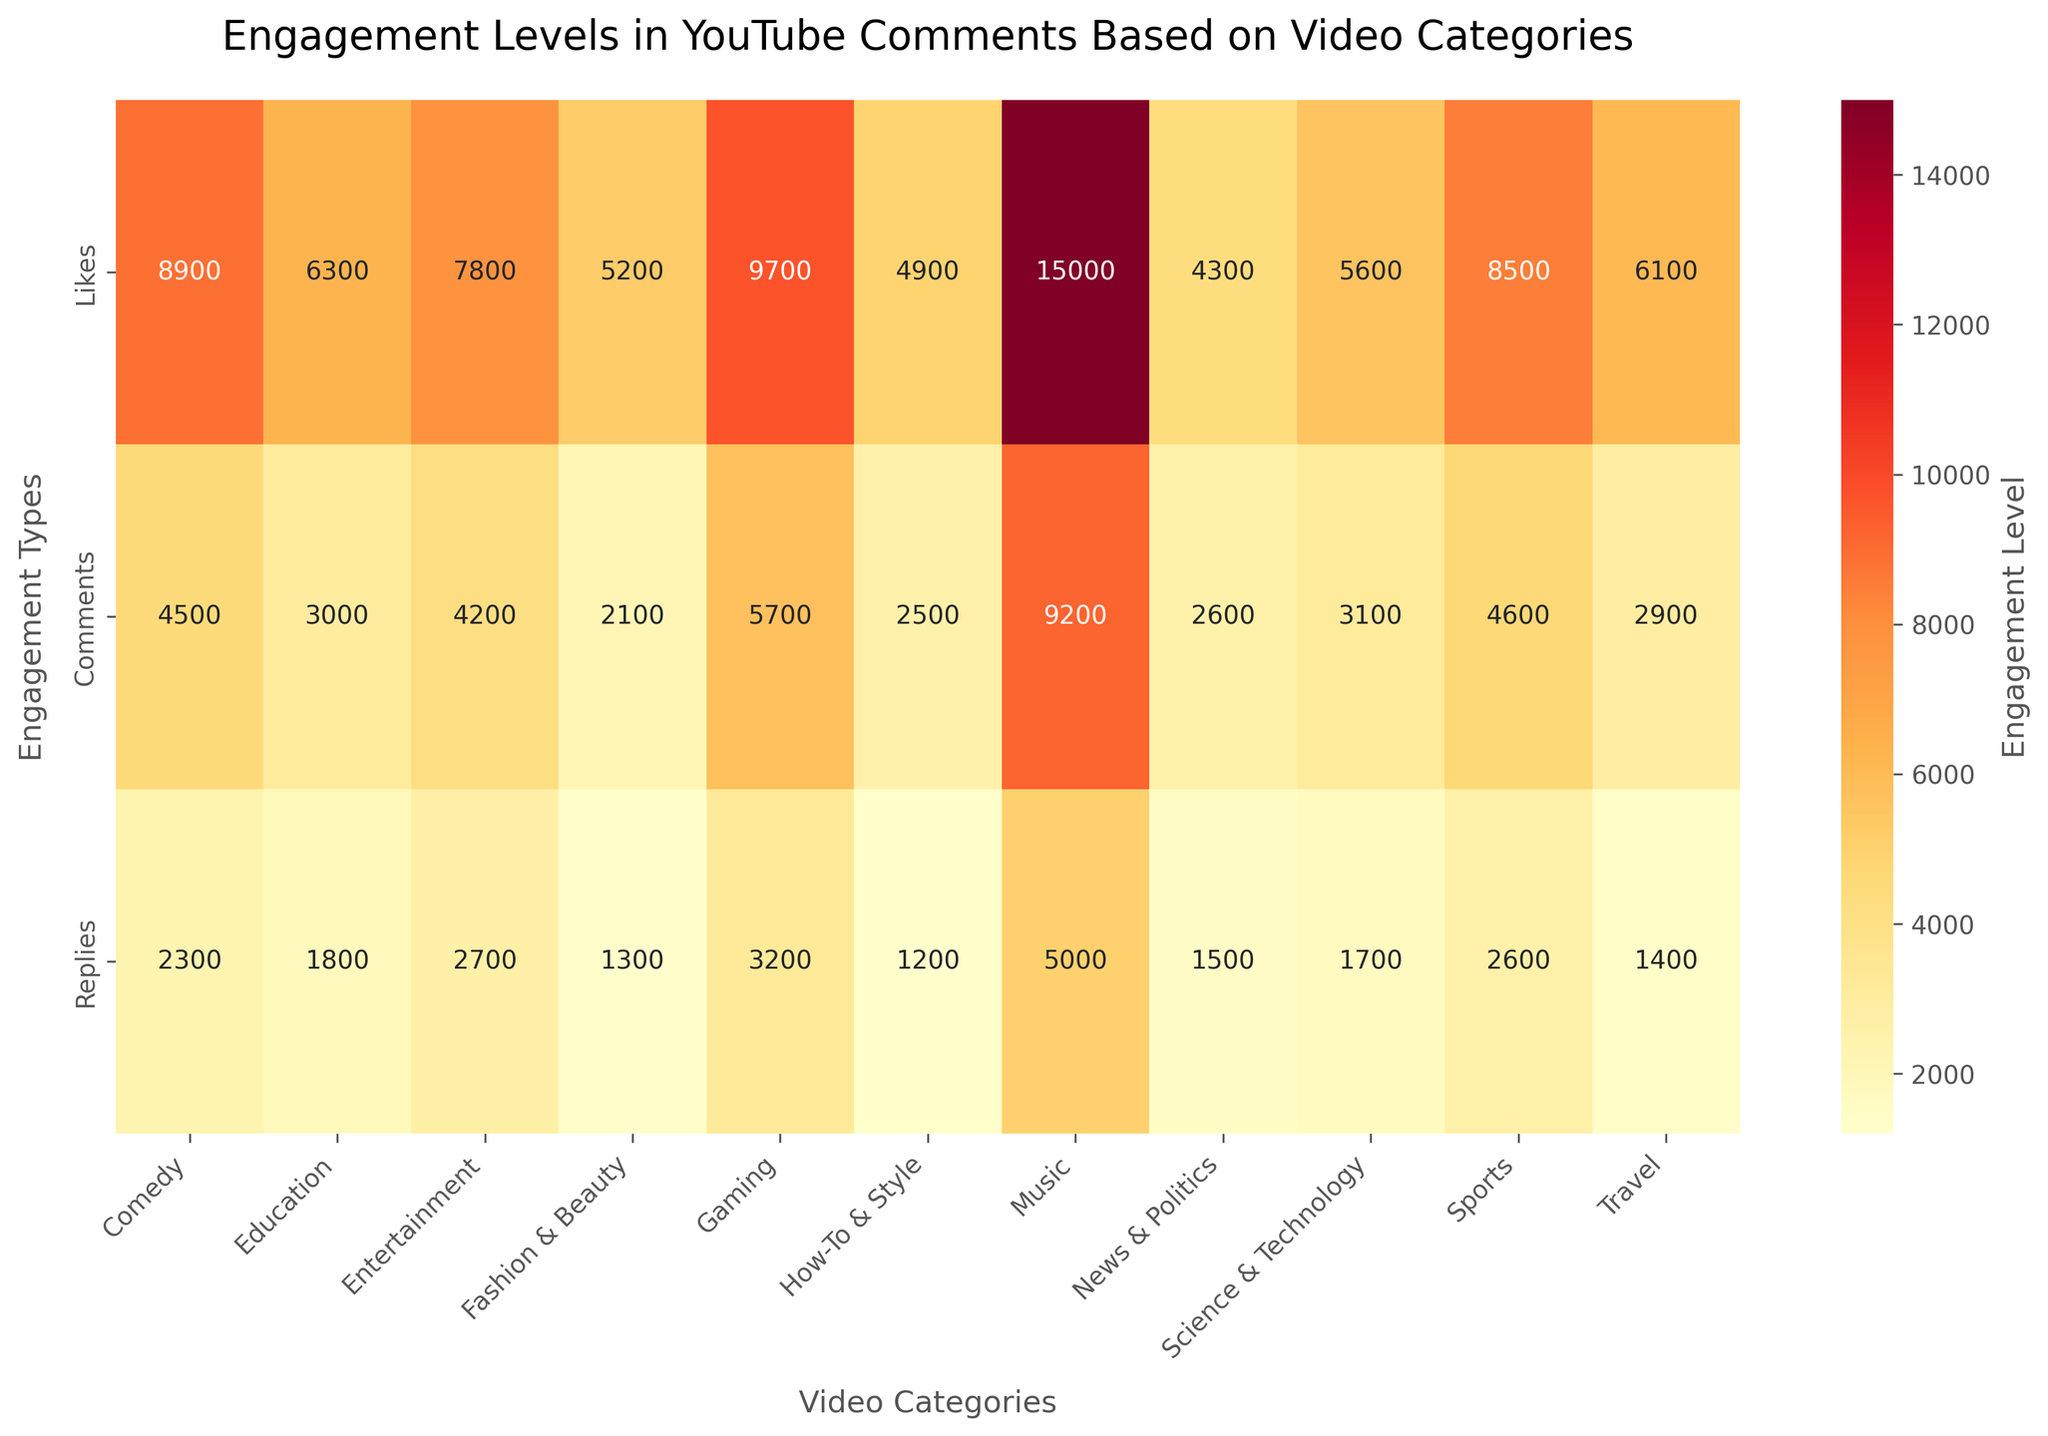What's the total number of likes for the categories with the highest and lowest engagement scores? Locate the categories with the highest and lowest 'Likes' values in the heatmap, which are 'Music' (15000) and 'How-To & Style' (4900) respectively. Sum these values: 15000 + 4900 = 19900.
Answer: 19900 What is the average number of comments across all categories? Sum the 'Comments' values across all categories and divide by the number of categories. (4500 + 3000 + 4200 + 2100 + 5700 + 2500 + 9200 + 2600 + 3100 + 4600 + 2900) / 11 = 4463.64
Answer: 4463.64 Which video category has the highest number of replies? Identify the number linked to 'Replies' and find the highest value, which is 'Music' with 5000.
Answer: Music How does the number of dislikes compare to the number of likes for the 'Gaming' category? Note that the heatmap only depicts likes, comments, and replies, but there is no mention of dislikes. This information cannot be extracted from the figure.
Answer: Not available Are there more comments or replies in the 'Science & Technology' category? Compare the values for 'Science & Technology' in the comments (3100) and replies (1700) rows. Comments (3100) > Replies (1700).
Answer: Comments What's the difference between the highest and lowest engagement levels for 'Comedy'? Locate 'Comedy' row and identify the max and min values among Likes, Comments, and Replies. The max is 'Likes' (8900) and the min is 'Replies' (2300). Difference: 8900 - 2300 = 6600.
Answer: 6600 What video category has the highest total engagement when considering all three metrics (likes, comments, replies)? Sum the 'Likes', 'Comments', and 'Replies' for each category and identify the highest overall sum. Analysis across all categories reveals that 'Music' has the highest total (15000 + 9200 + 5000 = 29200).
Answer: Music Which category has the least average engagement across all three metrics? Compute the average engagement (sum of likes, comments, and replies divided by 3) for each category and find the lowest average. 'How-To & Style' has the lowest average: (4900 + 2500 + 1200) / 3 ≈ 2867
Answer: How-To & Style How do the comments for 'Education' compare to the comments for 'News & Politics'? Locate the 'Comments' values for 'Education' (3000) and 'News & Politics' (2600). Education's comments (3000) > News & Politics' comments (2600).
Answer: Education What is the median value of replies across all categories? Extract and sort the 'Replies' values (2300, 1800, 2700, 1300, 3200, 1200, 5000, 1500, 1700, 2600, 1400) in ascending order: [1200, 1300, 1400, 1500, 1700, 1800, 2300, 2600, 2700, 3200, 5000]. The median value is the middle one (1800).
Answer: 1800 